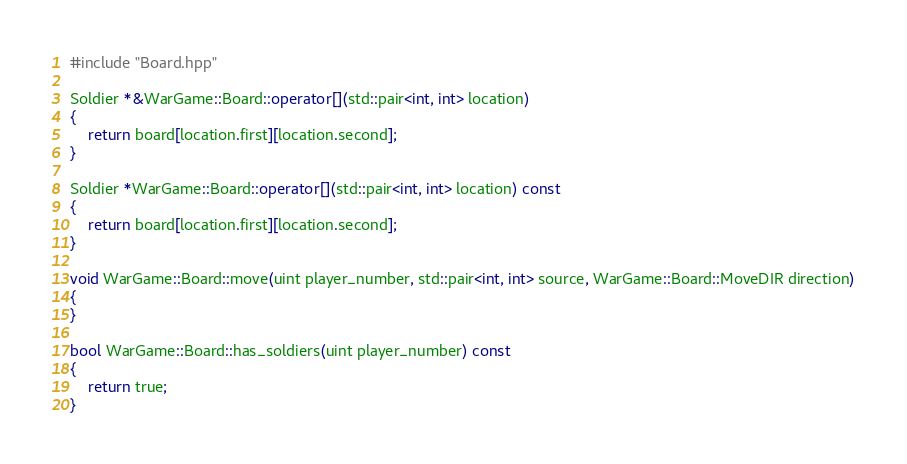<code> <loc_0><loc_0><loc_500><loc_500><_C++_>#include "Board.hpp"

Soldier *&WarGame::Board::operator[](std::pair<int, int> location)
{
    return board[location.first][location.second];
}

Soldier *WarGame::Board::operator[](std::pair<int, int> location) const
{
    return board[location.first][location.second];
}

void WarGame::Board::move(uint player_number, std::pair<int, int> source, WarGame::Board::MoveDIR direction)
{
}

bool WarGame::Board::has_soldiers(uint player_number) const
{
    return true;
}</code> 